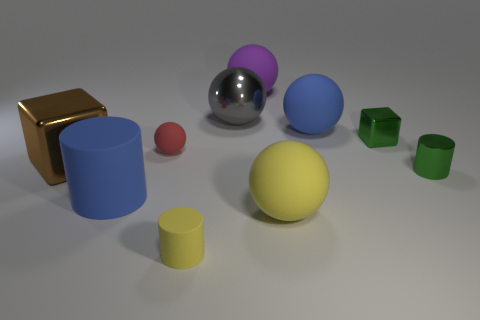How many spheres are on the left side of the large yellow sphere?
Provide a short and direct response. 3. There is a big ball that is made of the same material as the brown cube; what color is it?
Provide a short and direct response. Gray. How many rubber things are yellow balls or tiny green cubes?
Provide a short and direct response. 1. Do the brown block and the big gray object have the same material?
Offer a very short reply. Yes. There is a large metallic thing that is behind the large blue rubber sphere; what shape is it?
Your response must be concise. Sphere. There is a large blue thing that is to the left of the big purple thing; are there any objects that are on the right side of it?
Offer a terse response. Yes. Is there a green shiny block of the same size as the yellow cylinder?
Provide a succinct answer. Yes. Is the color of the small rubber cylinder that is in front of the purple ball the same as the small matte sphere?
Your answer should be compact. No. The shiny cylinder has what size?
Provide a succinct answer. Small. What size is the blue object that is on the left side of the big sphere that is in front of the large blue rubber ball?
Offer a terse response. Large. 